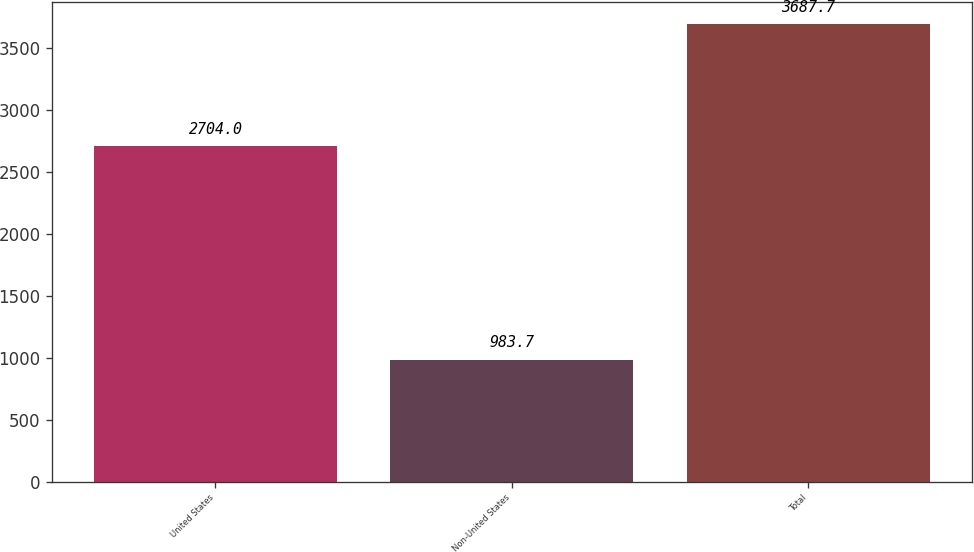<chart> <loc_0><loc_0><loc_500><loc_500><bar_chart><fcel>United States<fcel>Non-United States<fcel>Total<nl><fcel>2704<fcel>983.7<fcel>3687.7<nl></chart> 